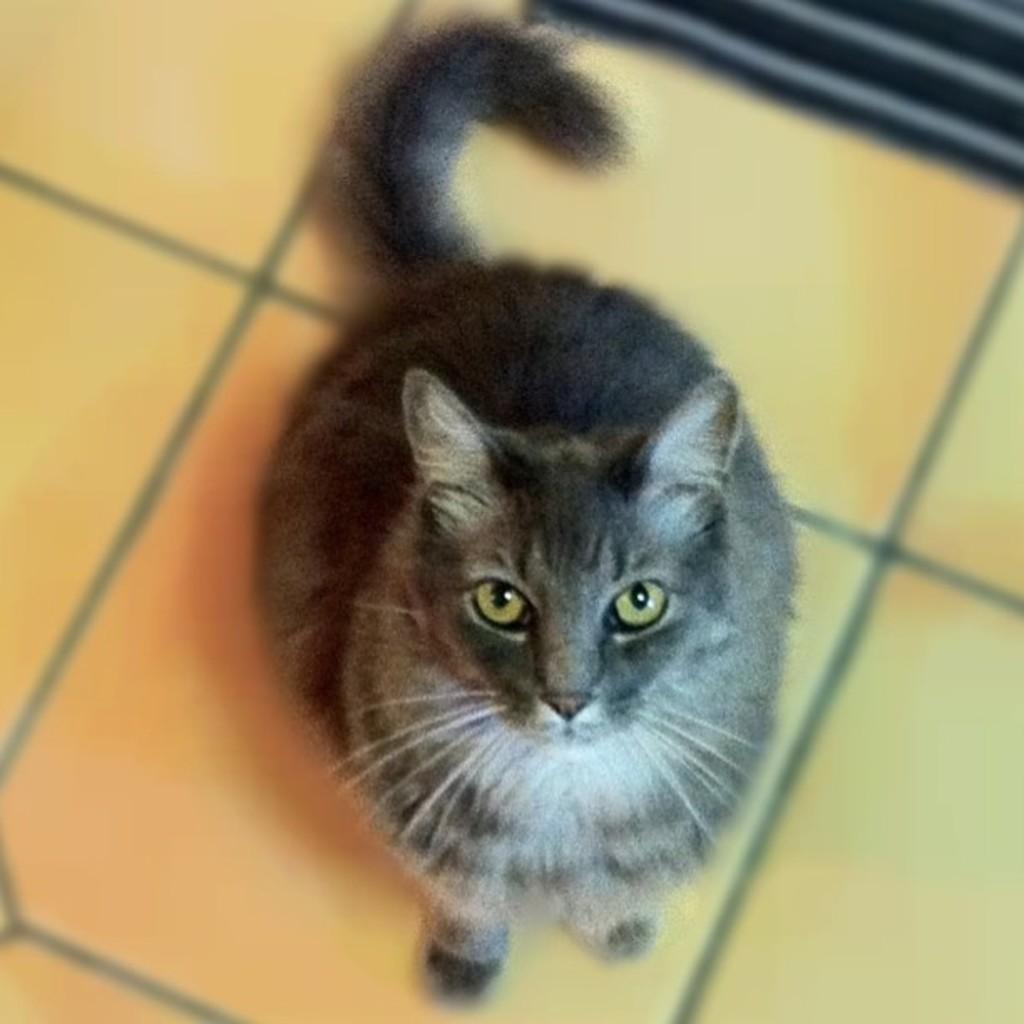Describe this image in one or two sentences. This picture contains a cat which is in black color is sitting on the floor. In the right top of the picture, it is black in color. This cat is looking at the camera. 